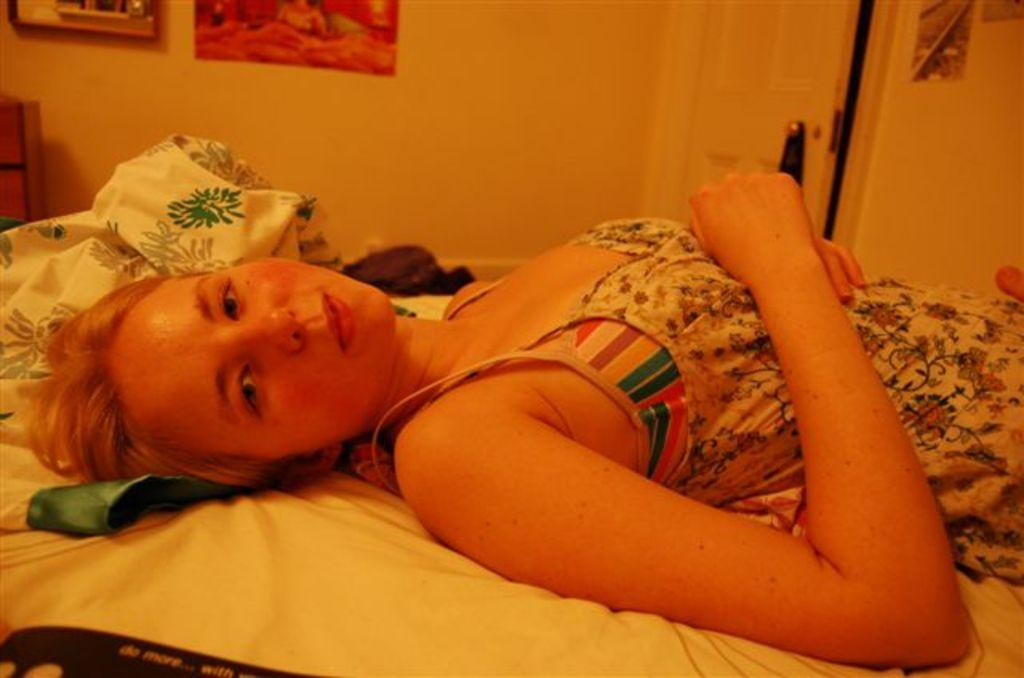Who is present in the image? There is a woman in the image. What is the woman doing in the image? The woman is sleeping on a bed. What is located beside the woman on the bed? There is a bed sheet beside the woman. What can be seen on the wall in the image? There is a wall with frames in the image. What is the other object visible in the image? There is a pole in the image. What type of lace is used to decorate the bed in the image? There is no lace visible in the image; it only shows a bed sheet beside the woman. 